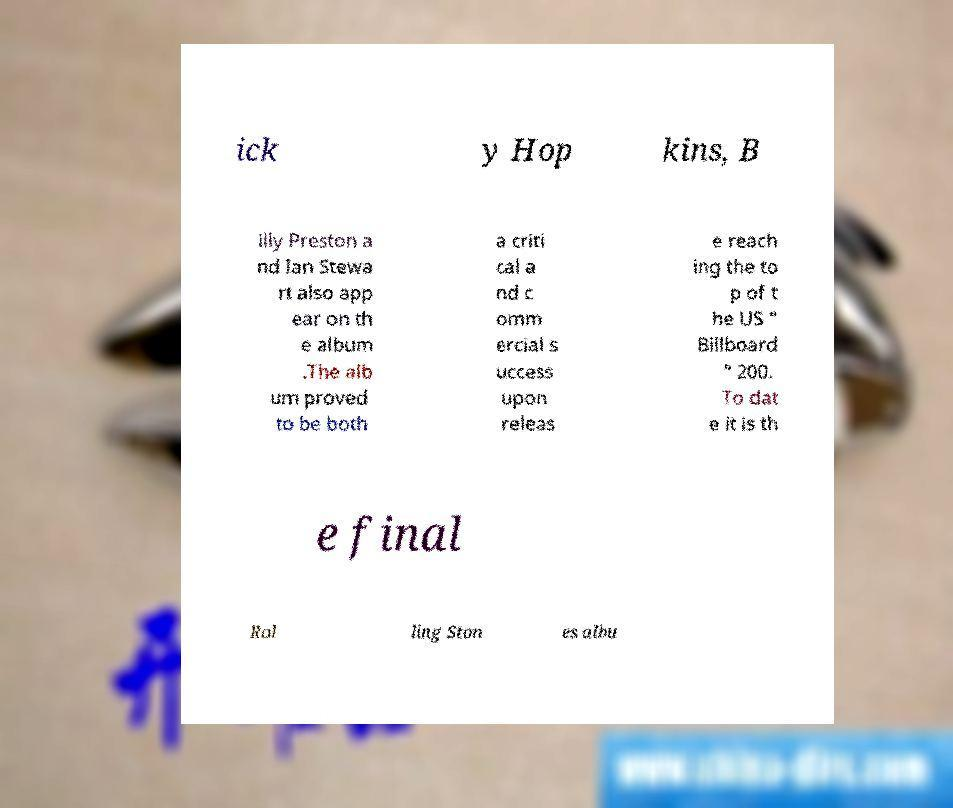Can you accurately transcribe the text from the provided image for me? ick y Hop kins, B illy Preston a nd Ian Stewa rt also app ear on th e album .The alb um proved to be both a criti cal a nd c omm ercial s uccess upon releas e reach ing the to p of t he US " Billboard " 200. To dat e it is th e final Rol ling Ston es albu 